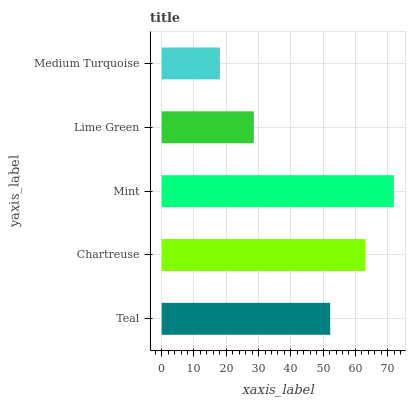Is Medium Turquoise the minimum?
Answer yes or no. Yes. Is Mint the maximum?
Answer yes or no. Yes. Is Chartreuse the minimum?
Answer yes or no. No. Is Chartreuse the maximum?
Answer yes or no. No. Is Chartreuse greater than Teal?
Answer yes or no. Yes. Is Teal less than Chartreuse?
Answer yes or no. Yes. Is Teal greater than Chartreuse?
Answer yes or no. No. Is Chartreuse less than Teal?
Answer yes or no. No. Is Teal the high median?
Answer yes or no. Yes. Is Teal the low median?
Answer yes or no. Yes. Is Lime Green the high median?
Answer yes or no. No. Is Chartreuse the low median?
Answer yes or no. No. 